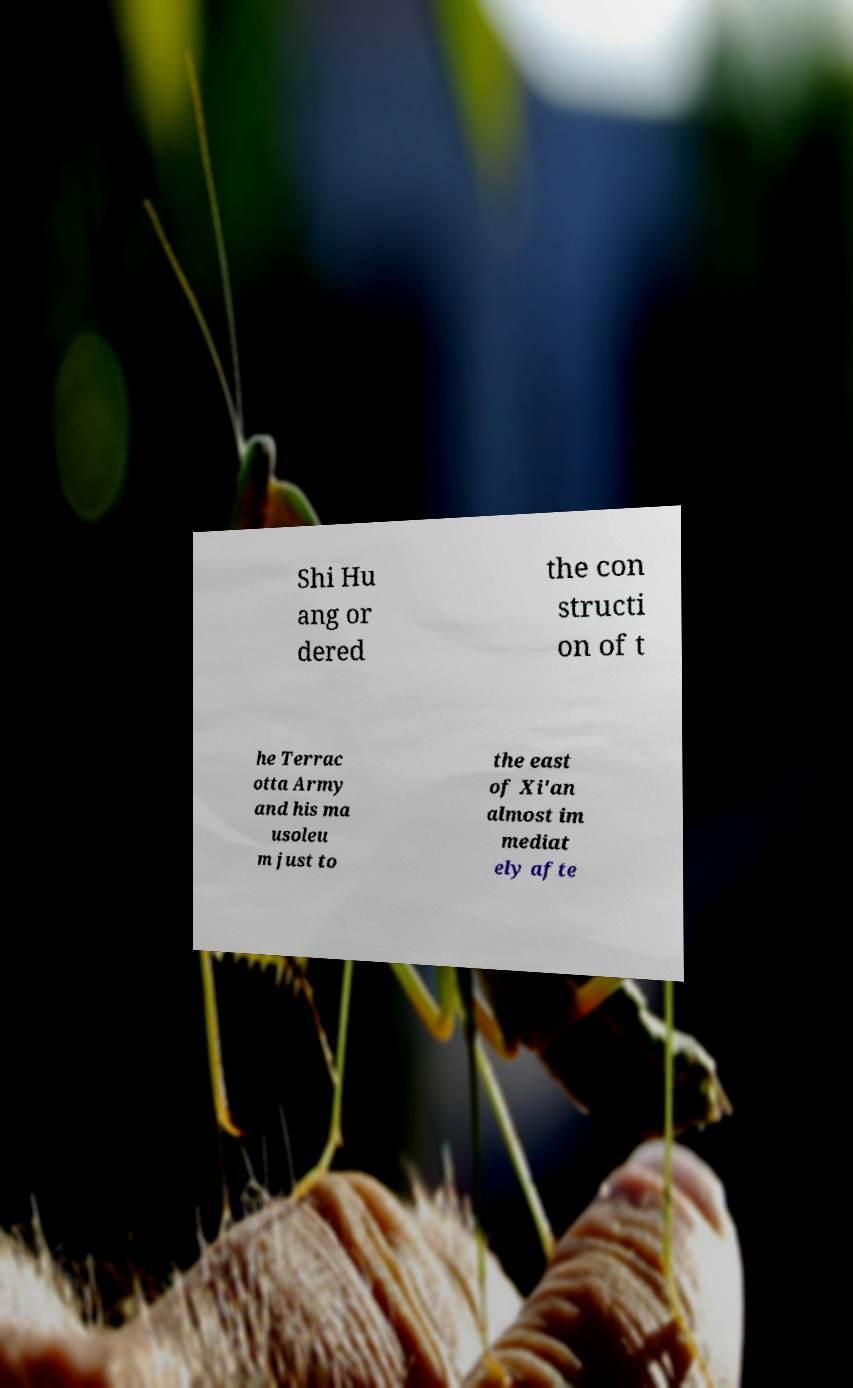Could you assist in decoding the text presented in this image and type it out clearly? Shi Hu ang or dered the con structi on of t he Terrac otta Army and his ma usoleu m just to the east of Xi'an almost im mediat ely afte 